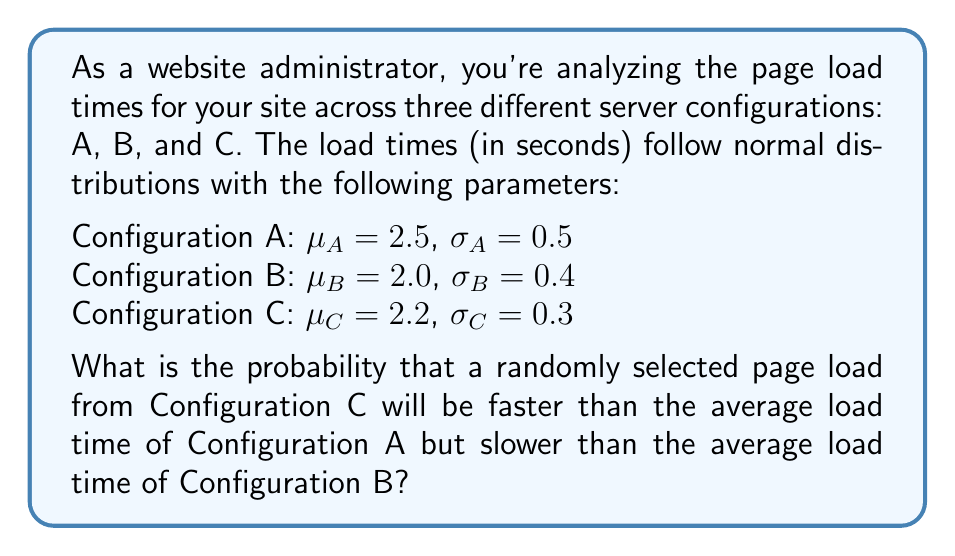Teach me how to tackle this problem. Let's approach this step-by-step:

1) We need to find $P(2.0 < X_C < 2.5)$, where $X_C$ is the random variable representing the load time for Configuration C.

2) For Configuration C, we have $\mu_C = 2.2$ and $\sigma_C = 0.3$.

3) To standardize this interval, we use the Z-score formula:
   $Z = \frac{X - \mu}{\sigma}$

4) For the lower bound: $Z_1 = \frac{2.0 - 2.2}{0.3} = -\frac{2}{3} \approx -0.67$

5) For the upper bound: $Z_2 = \frac{2.5 - 2.2}{0.3} = 1$

6) Now we need to find $P(-0.67 < Z < 1)$

7) Using the standard normal distribution table or a calculator:
   $P(Z < 1) = 0.8413$
   $P(Z < -0.67) = 0.2514$

8) The probability we're looking for is the difference:
   $P(-0.67 < Z < 1) = P(Z < 1) - P(Z < -0.67)$
   $= 0.8413 - 0.2514 = 0.5899$

Therefore, the probability is approximately 0.5899 or 58.99%.
Answer: 0.5899 